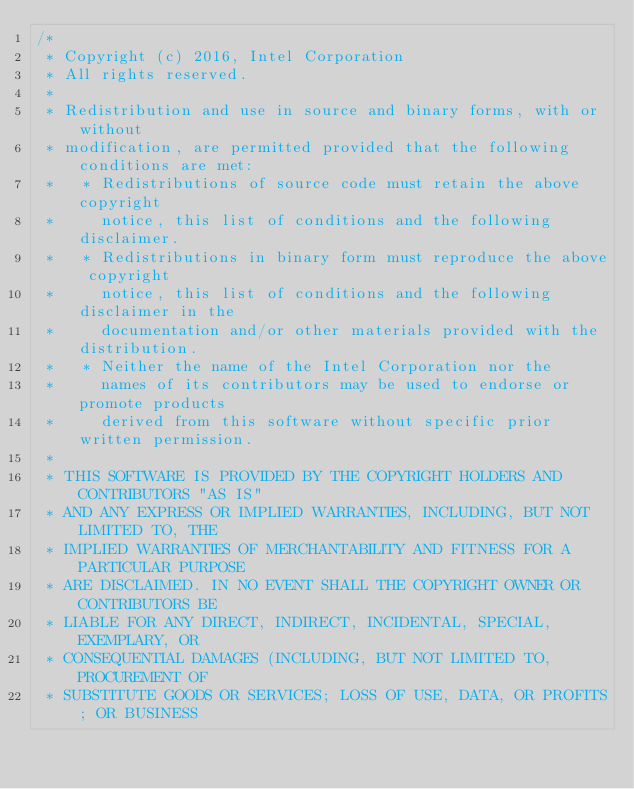Convert code to text. <code><loc_0><loc_0><loc_500><loc_500><_C_>/*
 * Copyright (c) 2016, Intel Corporation
 * All rights reserved.
 *
 * Redistribution and use in source and binary forms, with or without
 * modification, are permitted provided that the following conditions are met:
 *   * Redistributions of source code must retain the above copyright
 *     notice, this list of conditions and the following disclaimer.
 *   * Redistributions in binary form must reproduce the above copyright
 *     notice, this list of conditions and the following disclaimer in the
 *     documentation and/or other materials provided with the distribution.
 *   * Neither the name of the Intel Corporation nor the
 *     names of its contributors may be used to endorse or promote products
 *     derived from this software without specific prior written permission.
 *
 * THIS SOFTWARE IS PROVIDED BY THE COPYRIGHT HOLDERS AND CONTRIBUTORS "AS IS"
 * AND ANY EXPRESS OR IMPLIED WARRANTIES, INCLUDING, BUT NOT LIMITED TO, THE
 * IMPLIED WARRANTIES OF MERCHANTABILITY AND FITNESS FOR A PARTICULAR PURPOSE
 * ARE DISCLAIMED. IN NO EVENT SHALL THE COPYRIGHT OWNER OR CONTRIBUTORS BE
 * LIABLE FOR ANY DIRECT, INDIRECT, INCIDENTAL, SPECIAL, EXEMPLARY, OR
 * CONSEQUENTIAL DAMAGES (INCLUDING, BUT NOT LIMITED TO, PROCUREMENT OF
 * SUBSTITUTE GOODS OR SERVICES; LOSS OF USE, DATA, OR PROFITS; OR BUSINESS</code> 